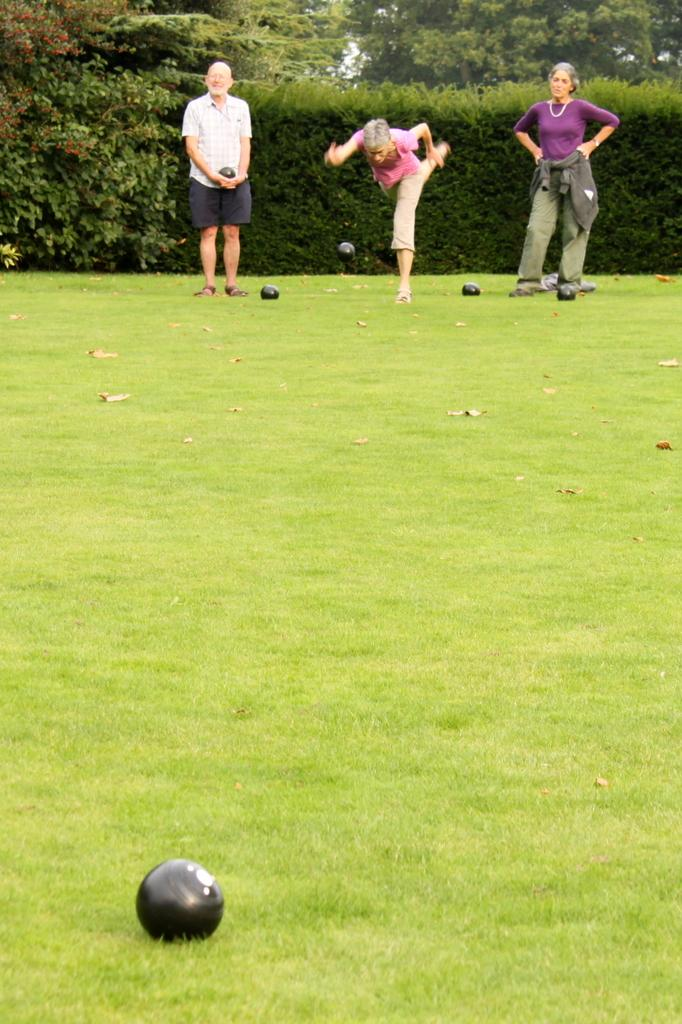Who or what is present in the image? There are people in the image. What objects are on the ground in the image? There are balls on the ground in the image. Is there any ball in motion in the image? Yes, one ball is in the air in the image. What can be seen in the background of the image? There are trees and plants in the background of the image. What type of record can be seen spinning on the ground in the image? There is no record present in the image; it features people, balls, and trees in the background. What voice can be heard coming from the trees in the background? There is no voice or sound coming from the trees in the image, as it is a still photograph. 